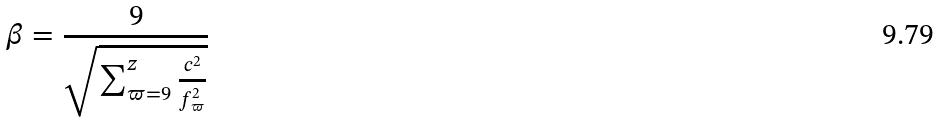<formula> <loc_0><loc_0><loc_500><loc_500>\beta = \frac { 9 } { \sqrt { \sum _ { \varpi = 9 } ^ { z } \frac { c ^ { 2 } } { f _ { \varpi } ^ { 2 } } } }</formula> 